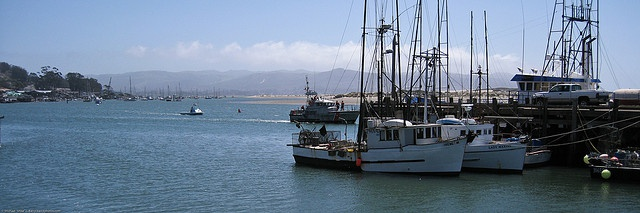Describe the objects in this image and their specific colors. I can see boat in gray, black, blue, and darkblue tones, boat in gray, black, darkblue, and blue tones, boat in gray, black, darkgray, and darkgreen tones, truck in gray, black, darkblue, and darkgray tones, and boat in gray, black, and darkgray tones in this image. 